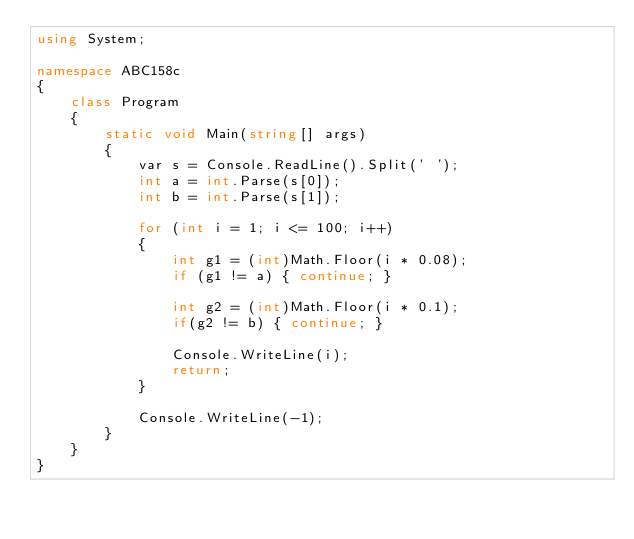<code> <loc_0><loc_0><loc_500><loc_500><_C#_>using System;

namespace ABC158c
{
    class Program
    {
        static void Main(string[] args)
        {
            var s = Console.ReadLine().Split(' ');
            int a = int.Parse(s[0]);
            int b = int.Parse(s[1]);

            for (int i = 1; i <= 100; i++)
            {
                int g1 = (int)Math.Floor(i * 0.08);
                if (g1 != a) { continue; }

                int g2 = (int)Math.Floor(i * 0.1);
                if(g2 != b) { continue; }

                Console.WriteLine(i);
                return;
            }

            Console.WriteLine(-1);
        }
    }
}
</code> 